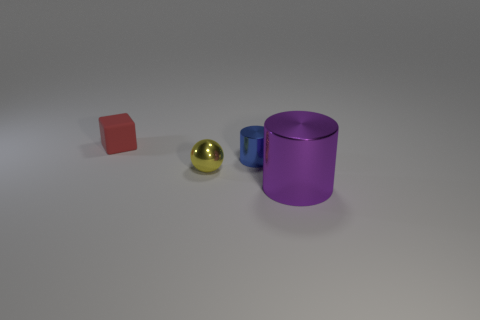Add 4 tiny metallic spheres. How many objects exist? 8 Subtract all spheres. How many objects are left? 3 Add 2 tiny red shiny things. How many tiny red shiny things exist? 2 Subtract 0 brown cylinders. How many objects are left? 4 Subtract all tiny cubes. Subtract all big cylinders. How many objects are left? 2 Add 3 blue things. How many blue things are left? 4 